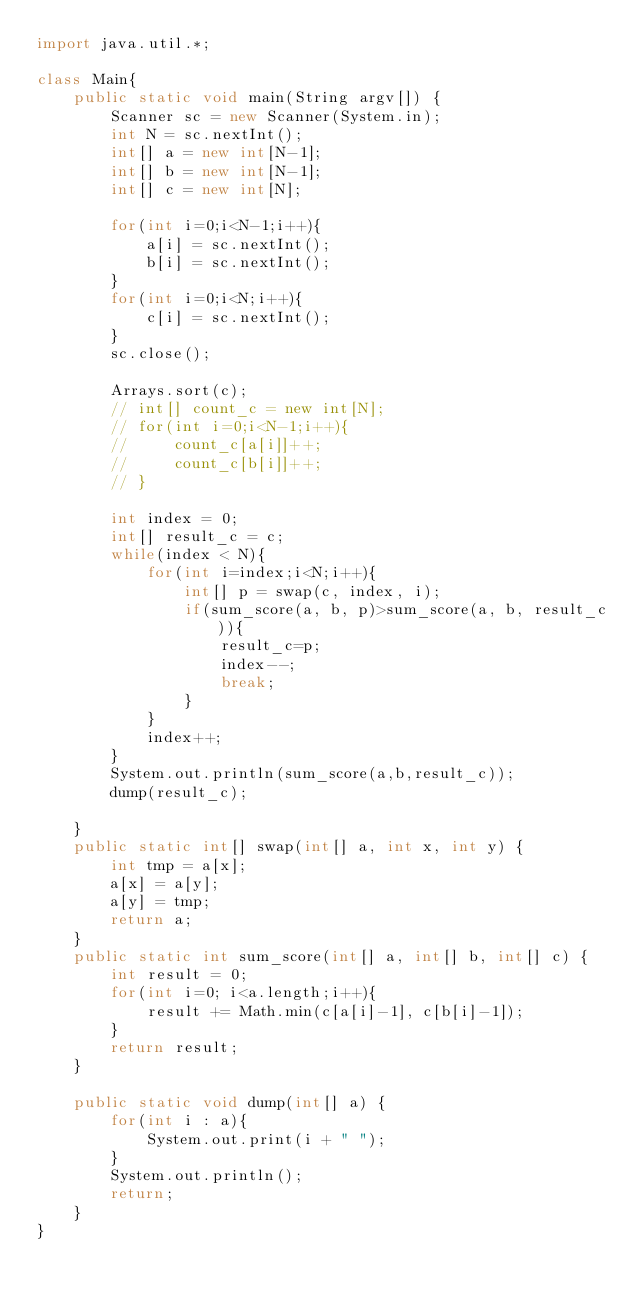Convert code to text. <code><loc_0><loc_0><loc_500><loc_500><_Java_>import java.util.*;

class Main{
    public static void main(String argv[]) {
        Scanner sc = new Scanner(System.in);
        int N = sc.nextInt();
        int[] a = new int[N-1];
        int[] b = new int[N-1];
        int[] c = new int[N];

        for(int i=0;i<N-1;i++){
            a[i] = sc.nextInt();
            b[i] = sc.nextInt();
        }
        for(int i=0;i<N;i++){
            c[i] = sc.nextInt();
        }
        sc.close();

        Arrays.sort(c);
        // int[] count_c = new int[N];
        // for(int i=0;i<N-1;i++){
        //     count_c[a[i]]++;
        //     count_c[b[i]]++;
        // }

        int index = 0;
        int[] result_c = c;
        while(index < N){
            for(int i=index;i<N;i++){
                int[] p = swap(c, index, i);
                if(sum_score(a, b, p)>sum_score(a, b, result_c)){
                    result_c=p;
                    index--;
                    break;
                }
            }
            index++;
        }
        System.out.println(sum_score(a,b,result_c));
        dump(result_c);

    }
    public static int[] swap(int[] a, int x, int y) {
        int tmp = a[x];
        a[x] = a[y];
        a[y] = tmp;
        return a;
    }
    public static int sum_score(int[] a, int[] b, int[] c) {
        int result = 0;
        for(int i=0; i<a.length;i++){
            result += Math.min(c[a[i]-1], c[b[i]-1]);
        }
        return result;
    }

    public static void dump(int[] a) {
        for(int i : a){
            System.out.print(i + " ");
        }
        System.out.println();
        return;
    }
}</code> 